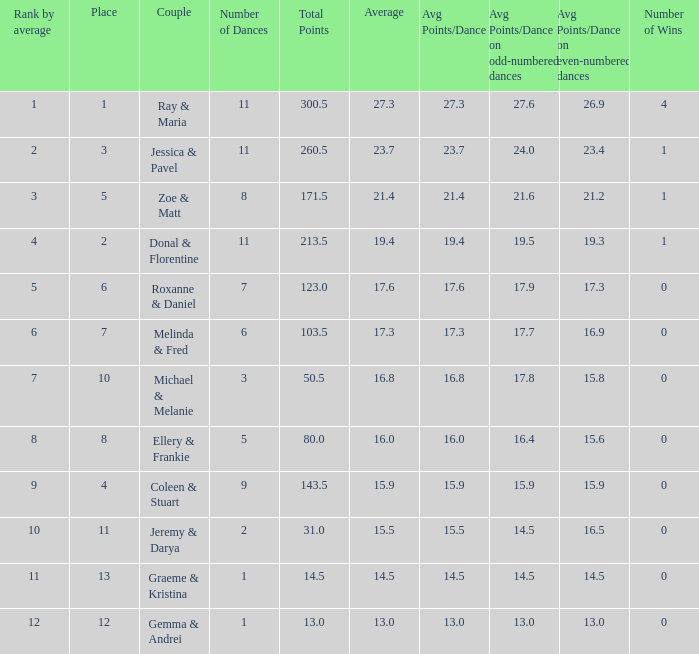What place would you be in if your rank by average is less than 2.0? 1.0. 